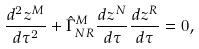<formula> <loc_0><loc_0><loc_500><loc_500>\frac { d ^ { 2 } z ^ { M } } { d \tau ^ { 2 } } + \hat { \Gamma } ^ { M } _ { N R } \frac { d z ^ { N } } { d \tau } \frac { d z ^ { R } } { d \tau } = 0 ,</formula> 